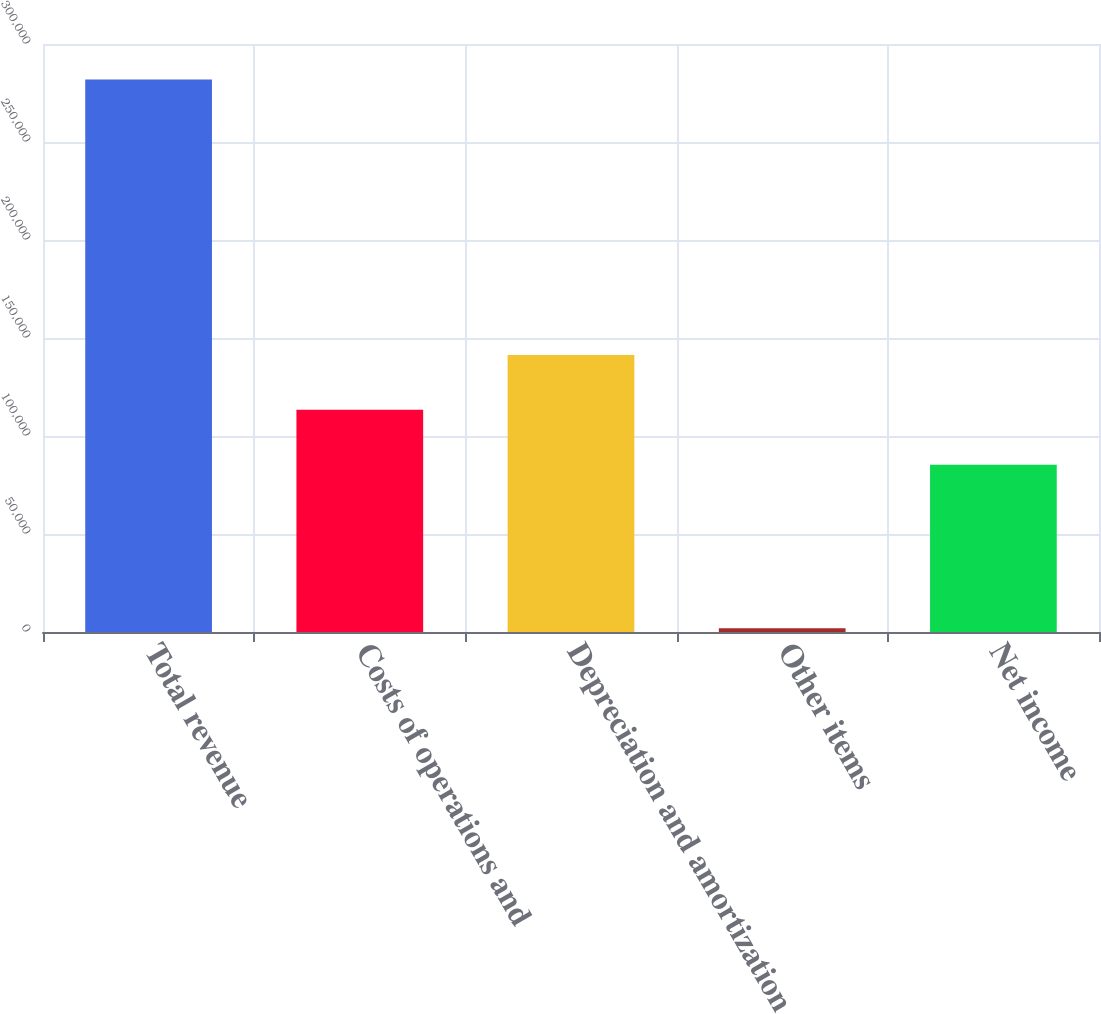Convert chart. <chart><loc_0><loc_0><loc_500><loc_500><bar_chart><fcel>Total revenue<fcel>Costs of operations and<fcel>Depreciation and amortization<fcel>Other items<fcel>Net income<nl><fcel>281843<fcel>113342<fcel>141336<fcel>1898<fcel>85347<nl></chart> 